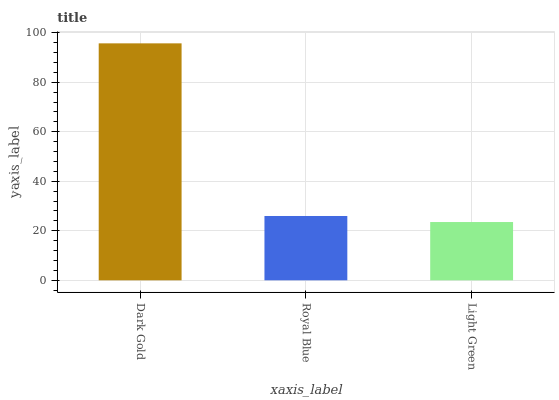Is Light Green the minimum?
Answer yes or no. Yes. Is Dark Gold the maximum?
Answer yes or no. Yes. Is Royal Blue the minimum?
Answer yes or no. No. Is Royal Blue the maximum?
Answer yes or no. No. Is Dark Gold greater than Royal Blue?
Answer yes or no. Yes. Is Royal Blue less than Dark Gold?
Answer yes or no. Yes. Is Royal Blue greater than Dark Gold?
Answer yes or no. No. Is Dark Gold less than Royal Blue?
Answer yes or no. No. Is Royal Blue the high median?
Answer yes or no. Yes. Is Royal Blue the low median?
Answer yes or no. Yes. Is Light Green the high median?
Answer yes or no. No. Is Light Green the low median?
Answer yes or no. No. 